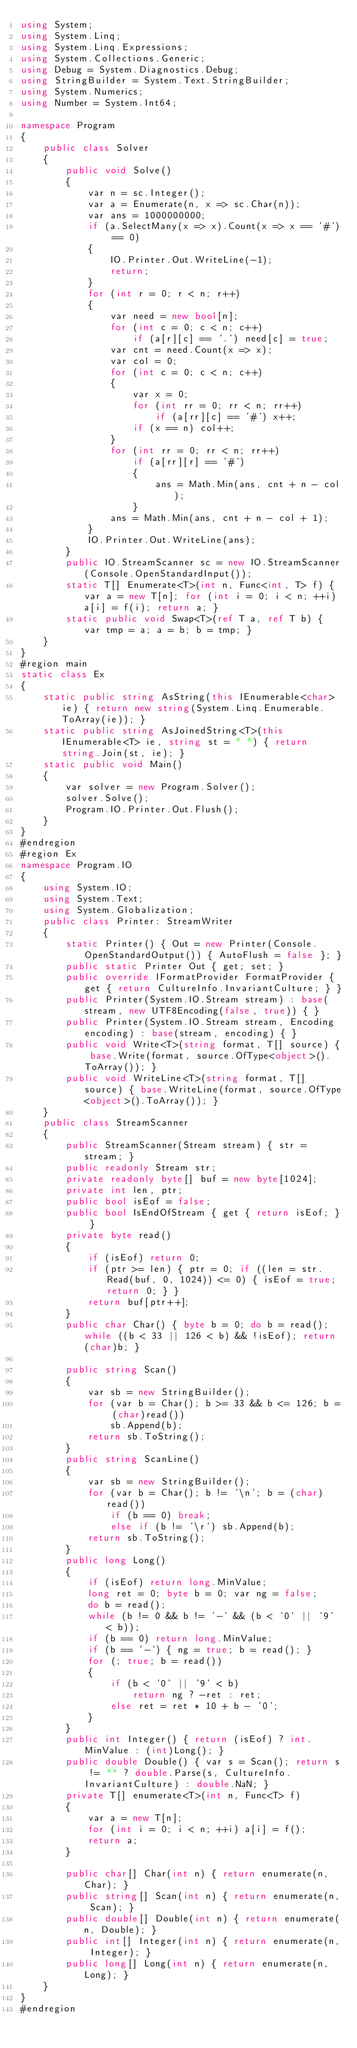Convert code to text. <code><loc_0><loc_0><loc_500><loc_500><_C#_>using System;
using System.Linq;
using System.Linq.Expressions;
using System.Collections.Generic;
using Debug = System.Diagnostics.Debug;
using StringBuilder = System.Text.StringBuilder;
using System.Numerics;
using Number = System.Int64;

namespace Program
{
    public class Solver
    {
        public void Solve()
        {
            var n = sc.Integer();
            var a = Enumerate(n, x => sc.Char(n));
            var ans = 1000000000;
            if (a.SelectMany(x => x).Count(x => x == '#') == 0)
            {
                IO.Printer.Out.WriteLine(-1);
                return;
            }
            for (int r = 0; r < n; r++)
            {
                var need = new bool[n];
                for (int c = 0; c < n; c++)
                    if (a[r][c] == '.') need[c] = true;
                var cnt = need.Count(x => x);
                var col = 0;
                for (int c = 0; c < n; c++)
                {
                    var x = 0;
                    for (int rr = 0; rr < n; rr++)
                        if (a[rr][c] == '#') x++;
                    if (x == n) col++;
                }
                for (int rr = 0; rr < n; rr++)
                    if (a[rr][r] == '#')
                    {
                        ans = Math.Min(ans, cnt + n - col);
                    }
                ans = Math.Min(ans, cnt + n - col + 1);
            }
            IO.Printer.Out.WriteLine(ans);
        }
        public IO.StreamScanner sc = new IO.StreamScanner(Console.OpenStandardInput());
        static T[] Enumerate<T>(int n, Func<int, T> f) { var a = new T[n]; for (int i = 0; i < n; ++i) a[i] = f(i); return a; }
        static public void Swap<T>(ref T a, ref T b) { var tmp = a; a = b; b = tmp; }
    }
}
#region main
static class Ex
{
    static public string AsString(this IEnumerable<char> ie) { return new string(System.Linq.Enumerable.ToArray(ie)); }
    static public string AsJoinedString<T>(this IEnumerable<T> ie, string st = " ") { return string.Join(st, ie); }
    static public void Main()
    {
        var solver = new Program.Solver();
        solver.Solve();
        Program.IO.Printer.Out.Flush();
    }
}
#endregion
#region Ex
namespace Program.IO
{
    using System.IO;
    using System.Text;
    using System.Globalization;
    public class Printer: StreamWriter
    {
        static Printer() { Out = new Printer(Console.OpenStandardOutput()) { AutoFlush = false }; }
        public static Printer Out { get; set; }
        public override IFormatProvider FormatProvider { get { return CultureInfo.InvariantCulture; } }
        public Printer(System.IO.Stream stream) : base(stream, new UTF8Encoding(false, true)) { }
        public Printer(System.IO.Stream stream, Encoding encoding) : base(stream, encoding) { }
        public void Write<T>(string format, T[] source) { base.Write(format, source.OfType<object>().ToArray()); }
        public void WriteLine<T>(string format, T[] source) { base.WriteLine(format, source.OfType<object>().ToArray()); }
    }
    public class StreamScanner
    {
        public StreamScanner(Stream stream) { str = stream; }
        public readonly Stream str;
        private readonly byte[] buf = new byte[1024];
        private int len, ptr;
        public bool isEof = false;
        public bool IsEndOfStream { get { return isEof; } }
        private byte read()
        {
            if (isEof) return 0;
            if (ptr >= len) { ptr = 0; if ((len = str.Read(buf, 0, 1024)) <= 0) { isEof = true; return 0; } }
            return buf[ptr++];
        }
        public char Char() { byte b = 0; do b = read(); while ((b < 33 || 126 < b) && !isEof); return (char)b; }

        public string Scan()
        {
            var sb = new StringBuilder();
            for (var b = Char(); b >= 33 && b <= 126; b = (char)read())
                sb.Append(b);
            return sb.ToString();
        }
        public string ScanLine()
        {
            var sb = new StringBuilder();
            for (var b = Char(); b != '\n'; b = (char)read())
                if (b == 0) break;
                else if (b != '\r') sb.Append(b);
            return sb.ToString();
        }
        public long Long()
        {
            if (isEof) return long.MinValue;
            long ret = 0; byte b = 0; var ng = false;
            do b = read();
            while (b != 0 && b != '-' && (b < '0' || '9' < b));
            if (b == 0) return long.MinValue;
            if (b == '-') { ng = true; b = read(); }
            for (; true; b = read())
            {
                if (b < '0' || '9' < b)
                    return ng ? -ret : ret;
                else ret = ret * 10 + b - '0';
            }
        }
        public int Integer() { return (isEof) ? int.MinValue : (int)Long(); }
        public double Double() { var s = Scan(); return s != "" ? double.Parse(s, CultureInfo.InvariantCulture) : double.NaN; }
        private T[] enumerate<T>(int n, Func<T> f)
        {
            var a = new T[n];
            for (int i = 0; i < n; ++i) a[i] = f();
            return a;
        }

        public char[] Char(int n) { return enumerate(n, Char); }
        public string[] Scan(int n) { return enumerate(n, Scan); }
        public double[] Double(int n) { return enumerate(n, Double); }
        public int[] Integer(int n) { return enumerate(n, Integer); }
        public long[] Long(int n) { return enumerate(n, Long); }
    }
}
#endregion


</code> 